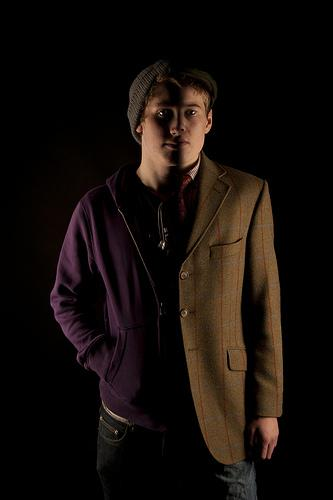Question: who is in the picture?
Choices:
A. Three different people.
B. Four different people.
C. Two different people.
D. One person.
Answer with the letter. Answer: C Question: what color is the sweatshirt?
Choices:
A. Red.
B. Purple.
C. Green.
D. Grey.
Answer with the letter. Answer: B Question: what color is the coat?
Choices:
A. Brown.
B. Olive.
C. Red.
D. Black.
Answer with the letter. Answer: B Question: what color are the pants?
Choices:
A. Green.
B. Brown.
C. Blue.
D. Black.
Answer with the letter. Answer: C Question: why are two people merged to make one?
Choices:
A. For science.
B. To look artistic.
C. To fit the story.
D. For interest.
Answer with the letter. Answer: B 